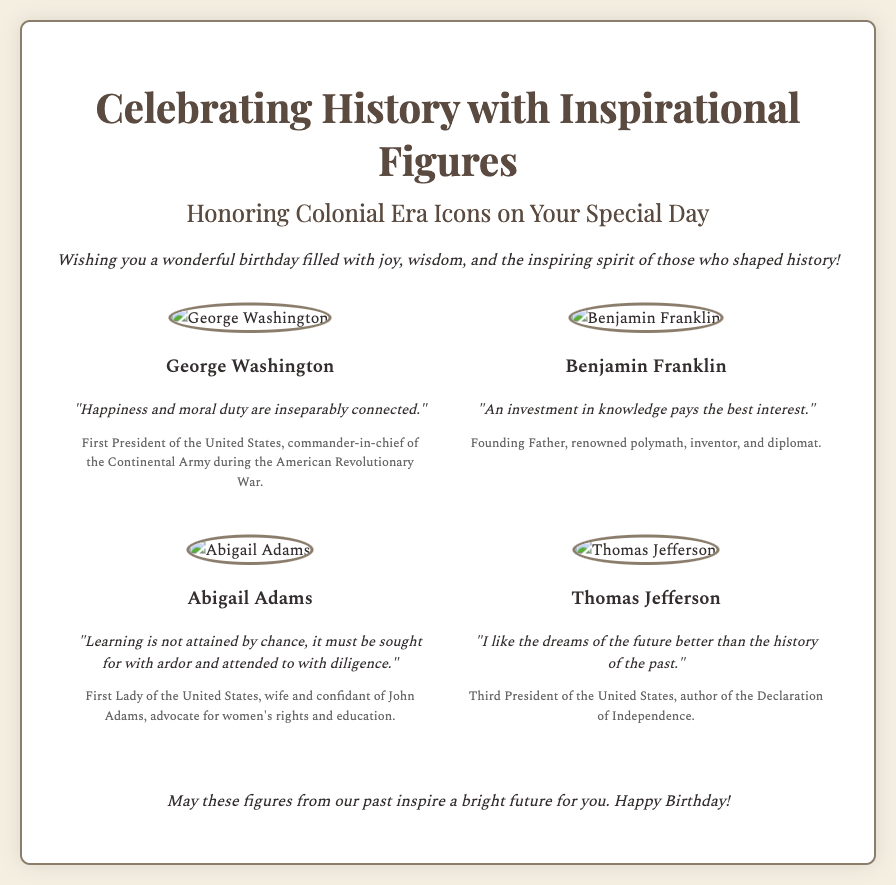What is the title of the card? The title of the card is prominently displayed at the top of the document.
Answer: Celebrating History with Inspirational Figures Who is featured as the first President of the United States? The document names a notable figure who served as the first President.
Answer: George Washington What is the quote attributed to Benjamin Franklin? The quote is provided alongside Franklin's name in the document.
Answer: "An investment in knowledge pays the best interest." How many historical figures are depicted on the card? By counting the number of figures presented in the card, we can determine this.
Answer: Four Which figure is associated with the quote about dreams of the future? The document lists a specific quote that relates to dreams, helping to identify the figure.
Answer: Thomas Jefferson What is the birthday wish included in the greeting? The greeting section contains a specific message for the birthday celebrant.
Answer: Wishing you a wonderful birthday filled with joy, wisdom, and the inspiring spirit of those who shaped history! Which figure is recognized as an advocate for women's rights? The description of one of the figures notes their advocacy for women's rights, allowing us to identify who that is.
Answer: Abigail Adams What type of card is this document? The overall theme and purpose of the document are specific to a category of greeting cards.
Answer: Birthday Card 